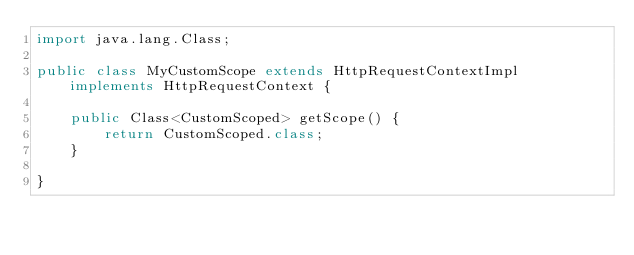Convert code to text. <code><loc_0><loc_0><loc_500><loc_500><_Java_>import java.lang.Class;

public class MyCustomScope extends HttpRequestContextImpl implements HttpRequestContext {

	public Class<CustomScoped> getScope() {
		return CustomScoped.class;
	}
	
}
</code> 